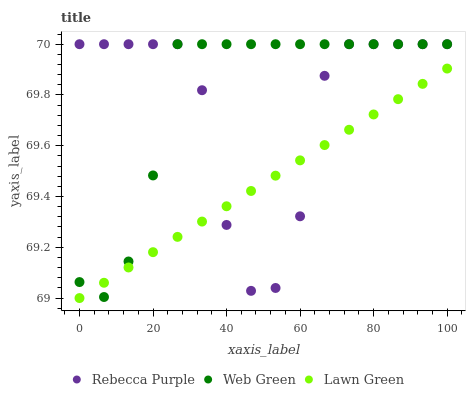Does Lawn Green have the minimum area under the curve?
Answer yes or no. Yes. Does Web Green have the maximum area under the curve?
Answer yes or no. Yes. Does Rebecca Purple have the minimum area under the curve?
Answer yes or no. No. Does Rebecca Purple have the maximum area under the curve?
Answer yes or no. No. Is Lawn Green the smoothest?
Answer yes or no. Yes. Is Rebecca Purple the roughest?
Answer yes or no. Yes. Is Web Green the smoothest?
Answer yes or no. No. Is Web Green the roughest?
Answer yes or no. No. Does Lawn Green have the lowest value?
Answer yes or no. Yes. Does Web Green have the lowest value?
Answer yes or no. No. Does Web Green have the highest value?
Answer yes or no. Yes. Does Lawn Green intersect Rebecca Purple?
Answer yes or no. Yes. Is Lawn Green less than Rebecca Purple?
Answer yes or no. No. Is Lawn Green greater than Rebecca Purple?
Answer yes or no. No. 